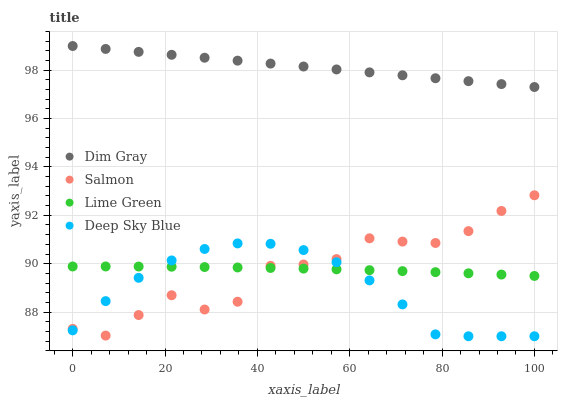Does Deep Sky Blue have the minimum area under the curve?
Answer yes or no. Yes. Does Dim Gray have the maximum area under the curve?
Answer yes or no. Yes. Does Salmon have the minimum area under the curve?
Answer yes or no. No. Does Salmon have the maximum area under the curve?
Answer yes or no. No. Is Dim Gray the smoothest?
Answer yes or no. Yes. Is Salmon the roughest?
Answer yes or no. Yes. Is Salmon the smoothest?
Answer yes or no. No. Is Dim Gray the roughest?
Answer yes or no. No. Does Deep Sky Blue have the lowest value?
Answer yes or no. Yes. Does Salmon have the lowest value?
Answer yes or no. No. Does Dim Gray have the highest value?
Answer yes or no. Yes. Does Salmon have the highest value?
Answer yes or no. No. Is Deep Sky Blue less than Dim Gray?
Answer yes or no. Yes. Is Dim Gray greater than Deep Sky Blue?
Answer yes or no. Yes. Does Deep Sky Blue intersect Lime Green?
Answer yes or no. Yes. Is Deep Sky Blue less than Lime Green?
Answer yes or no. No. Is Deep Sky Blue greater than Lime Green?
Answer yes or no. No. Does Deep Sky Blue intersect Dim Gray?
Answer yes or no. No. 